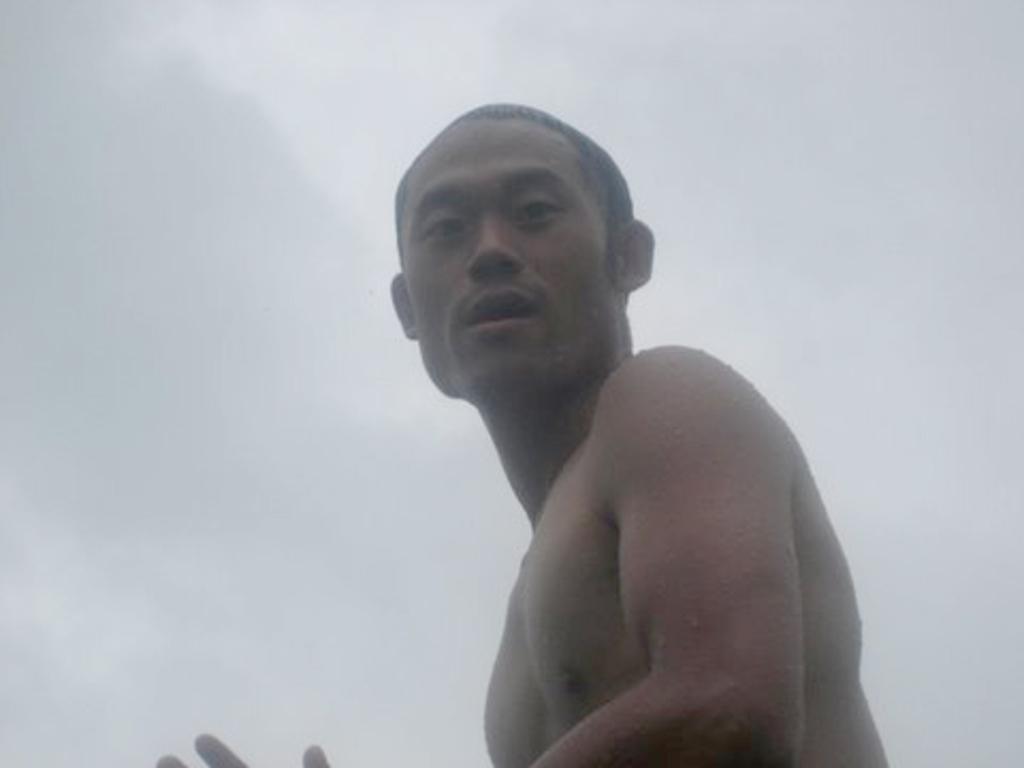Please provide a concise description of this image. This image is taken outdoors. In the background there is a sky with clouds. In the middle of the image there is a man. 